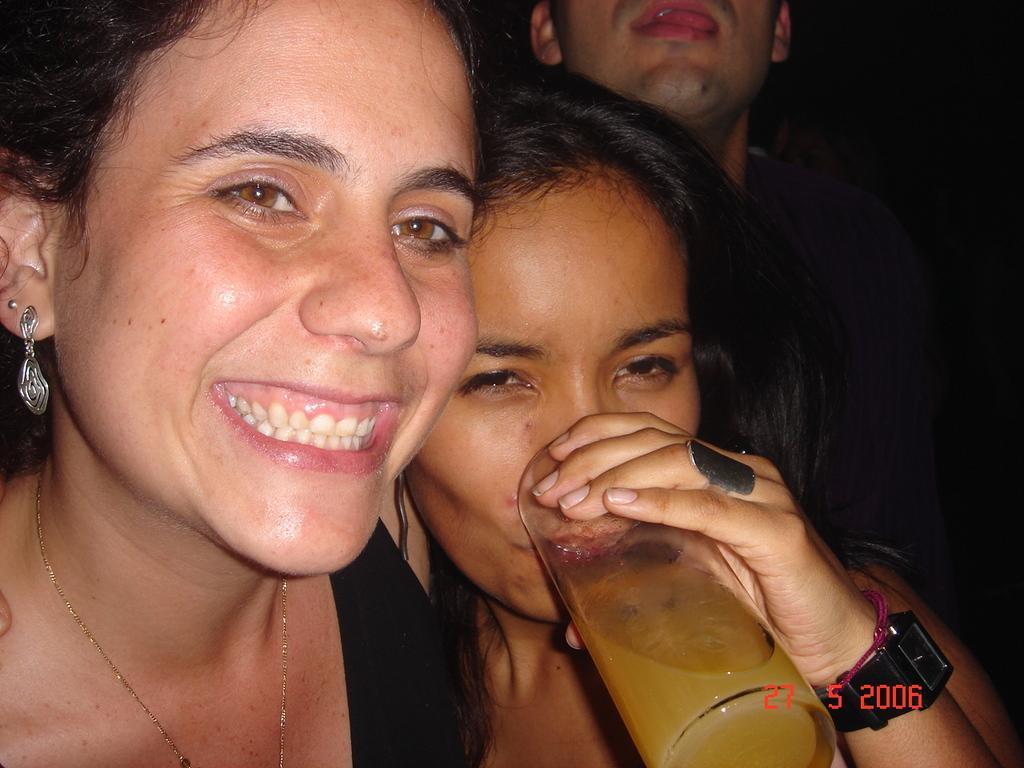Describe this image in one or two sentences. In this image there are group of people standing together in which one of them is drinking juice with glass. 